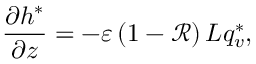Convert formula to latex. <formula><loc_0><loc_0><loc_500><loc_500>\frac { \partial h ^ { * } } { \partial z } = - \varepsilon \left ( 1 - \mathcal { R } \right ) L q _ { v } ^ { * } ,</formula> 